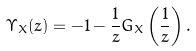Convert formula to latex. <formula><loc_0><loc_0><loc_500><loc_500>\Upsilon _ { X } ( z ) = - 1 - \frac { 1 } { z } G _ { X } \left ( \frac { 1 } { z } \right ) .</formula> 